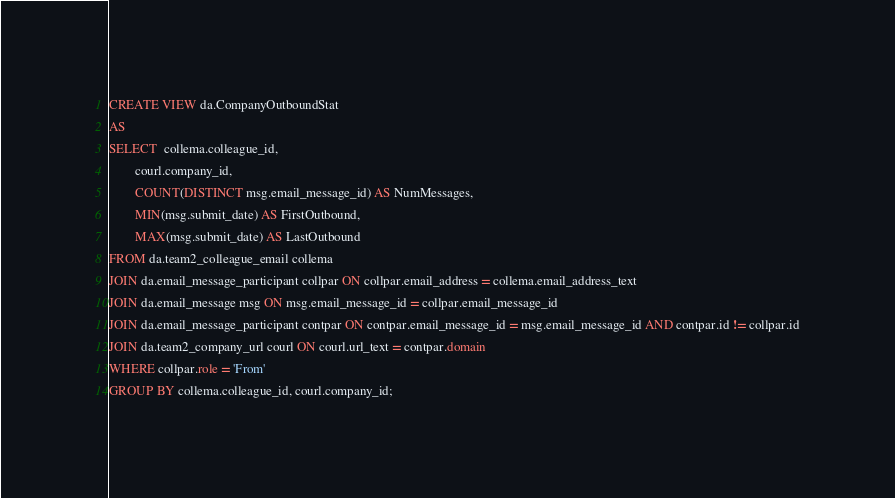<code> <loc_0><loc_0><loc_500><loc_500><_SQL_>
CREATE VIEW da.CompanyOutboundStat
AS
SELECT  collema.colleague_id,
        courl.company_id,
        COUNT(DISTINCT msg.email_message_id) AS NumMessages,
        MIN(msg.submit_date) AS FirstOutbound,
        MAX(msg.submit_date) AS LastOutbound
FROM da.team2_colleague_email collema
JOIN da.email_message_participant collpar ON collpar.email_address = collema.email_address_text
JOIN da.email_message msg ON msg.email_message_id = collpar.email_message_id
JOIN da.email_message_participant contpar ON contpar.email_message_id = msg.email_message_id AND contpar.id != collpar.id
JOIN da.team2_company_url courl ON courl.url_text = contpar.domain
WHERE collpar.role = 'From'
GROUP BY collema.colleague_id, courl.company_id;
</code> 